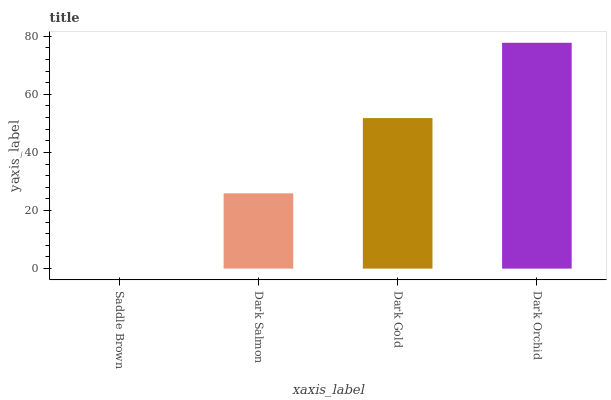Is Saddle Brown the minimum?
Answer yes or no. Yes. Is Dark Orchid the maximum?
Answer yes or no. Yes. Is Dark Salmon the minimum?
Answer yes or no. No. Is Dark Salmon the maximum?
Answer yes or no. No. Is Dark Salmon greater than Saddle Brown?
Answer yes or no. Yes. Is Saddle Brown less than Dark Salmon?
Answer yes or no. Yes. Is Saddle Brown greater than Dark Salmon?
Answer yes or no. No. Is Dark Salmon less than Saddle Brown?
Answer yes or no. No. Is Dark Gold the high median?
Answer yes or no. Yes. Is Dark Salmon the low median?
Answer yes or no. Yes. Is Dark Salmon the high median?
Answer yes or no. No. Is Dark Gold the low median?
Answer yes or no. No. 